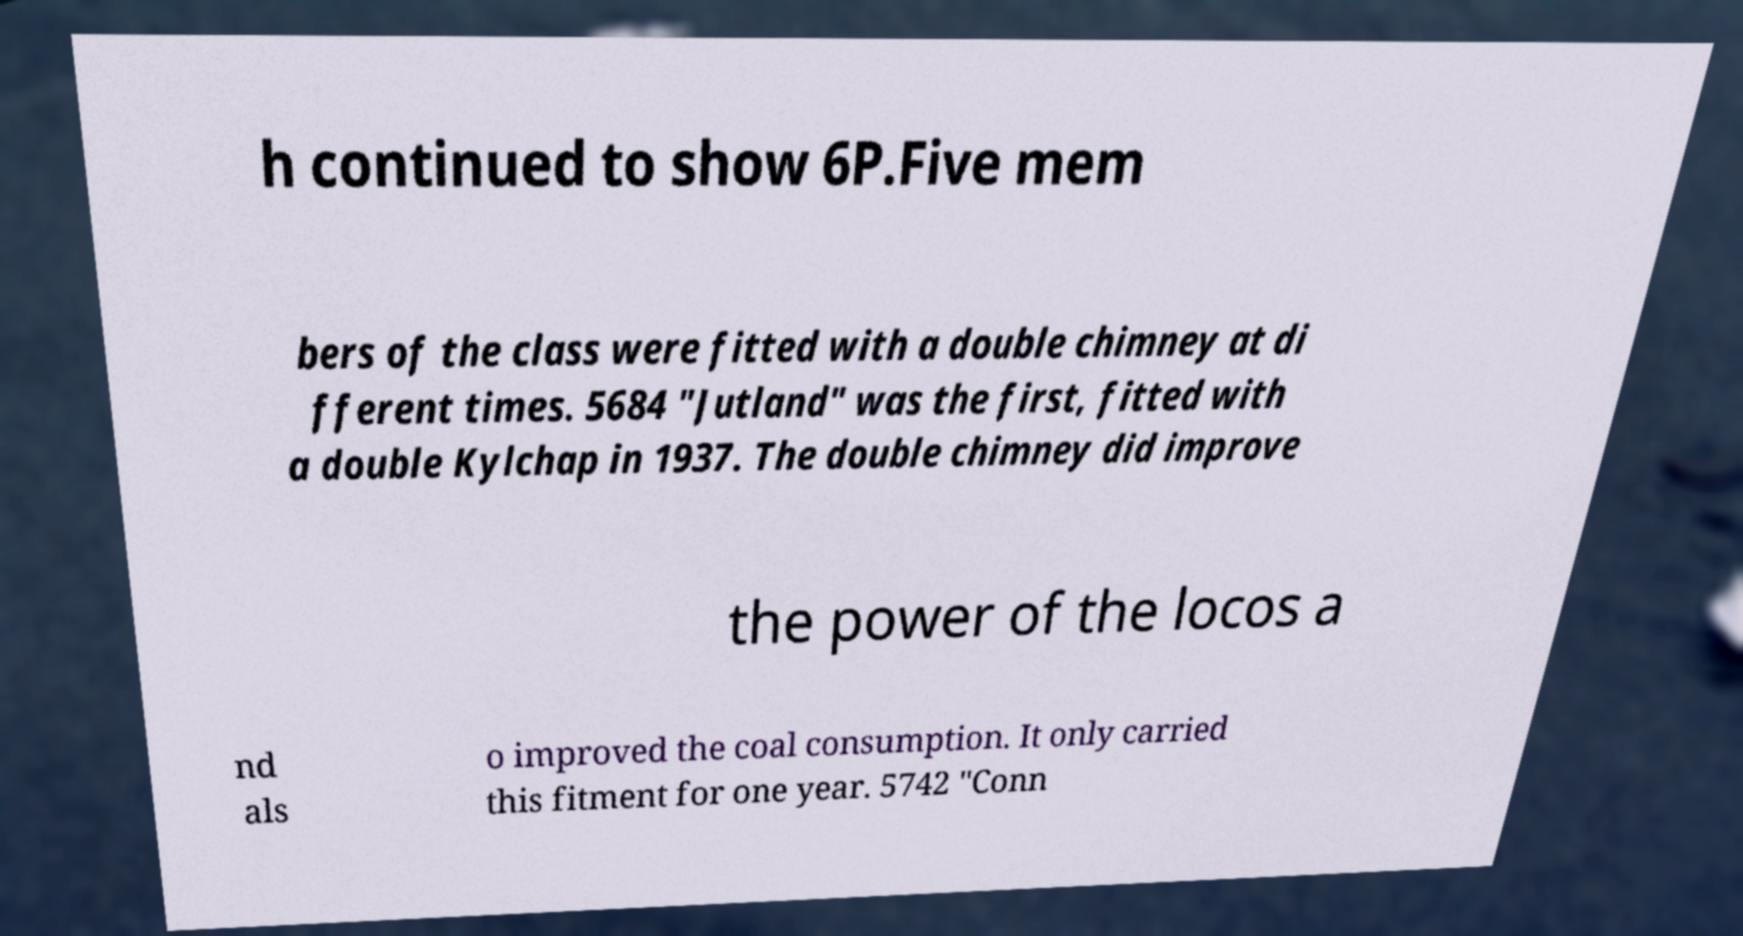I need the written content from this picture converted into text. Can you do that? h continued to show 6P.Five mem bers of the class were fitted with a double chimney at di fferent times. 5684 "Jutland" was the first, fitted with a double Kylchap in 1937. The double chimney did improve the power of the locos a nd als o improved the coal consumption. It only carried this fitment for one year. 5742 "Conn 